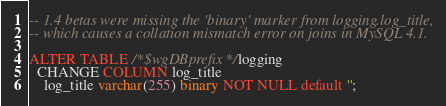Convert code to text. <code><loc_0><loc_0><loc_500><loc_500><_SQL_>-- 1.4 betas were missing the 'binary' marker from logging.log_title,
-- which causes a collation mismatch error on joins in MySQL 4.1.

ALTER TABLE /*$wgDBprefix*/logging
  CHANGE COLUMN log_title
    log_title varchar(255) binary NOT NULL default '';
</code> 